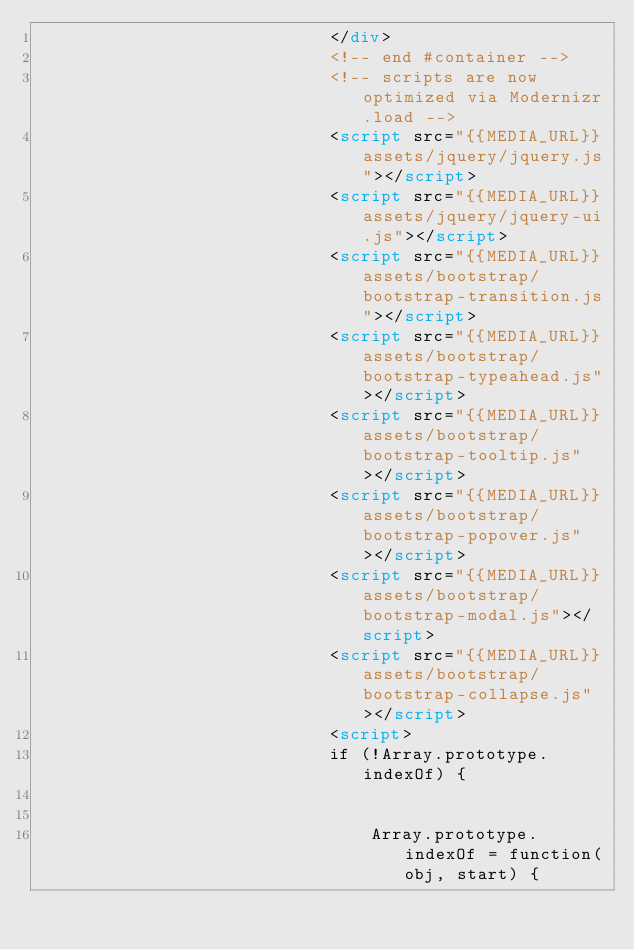Convert code to text. <code><loc_0><loc_0><loc_500><loc_500><_HTML_>                            </div>
                            <!-- end #container -->
                            <!-- scripts are now optimized via Modernizr.load -->
                            <script src="{{MEDIA_URL}}assets/jquery/jquery.js"></script>
                            <script src="{{MEDIA_URL}}assets/jquery/jquery-ui.js"></script>
                            <script src="{{MEDIA_URL}}assets/bootstrap/bootstrap-transition.js"></script>
                            <script src="{{MEDIA_URL}}assets/bootstrap/bootstrap-typeahead.js"></script>
                            <script src="{{MEDIA_URL}}assets/bootstrap/bootstrap-tooltip.js"></script>
                            <script src="{{MEDIA_URL}}assets/bootstrap/bootstrap-popover.js"></script>
                            <script src="{{MEDIA_URL}}assets/bootstrap/bootstrap-modal.js"></script>
                            <script src="{{MEDIA_URL}}assets/bootstrap/bootstrap-collapse.js"></script>
                            <script>
                            if (!Array.prototype.indexOf) {


                                Array.prototype.indexOf = function(obj, start) {</code> 